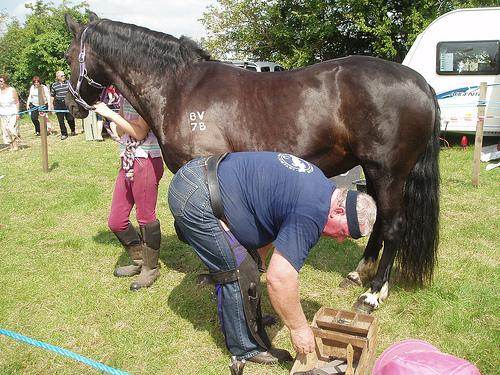Question: what animal is in the photo?
Choices:
A. Horse.
B. Mule.
C. Goat.
D. Sheep.
Answer with the letter. Answer: A Question: where is the horse standing?
Choices:
A. Hay.
B. Dirt.
C. Grass.
D. Gravel.
Answer with the letter. Answer: C Question: what color is the girls pants holding the horse?
Choices:
A. Black.
B. Blue.
C. Maroon.
D. Brown.
Answer with the letter. Answer: C Question: how many horses?
Choices:
A. One.
B. Two.
C. Four.
D. Three.
Answer with the letter. Answer: A 